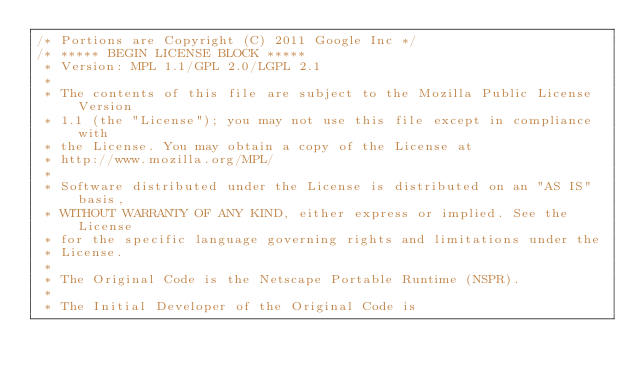Convert code to text. <code><loc_0><loc_0><loc_500><loc_500><_C_>/* Portions are Copyright (C) 2011 Google Inc */
/* ***** BEGIN LICENSE BLOCK *****
 * Version: MPL 1.1/GPL 2.0/LGPL 2.1
 *
 * The contents of this file are subject to the Mozilla Public License Version
 * 1.1 (the "License"); you may not use this file except in compliance with
 * the License. You may obtain a copy of the License at
 * http://www.mozilla.org/MPL/
 *
 * Software distributed under the License is distributed on an "AS IS" basis,
 * WITHOUT WARRANTY OF ANY KIND, either express or implied. See the License
 * for the specific language governing rights and limitations under the
 * License.
 *
 * The Original Code is the Netscape Portable Runtime (NSPR).
 *
 * The Initial Developer of the Original Code is</code> 